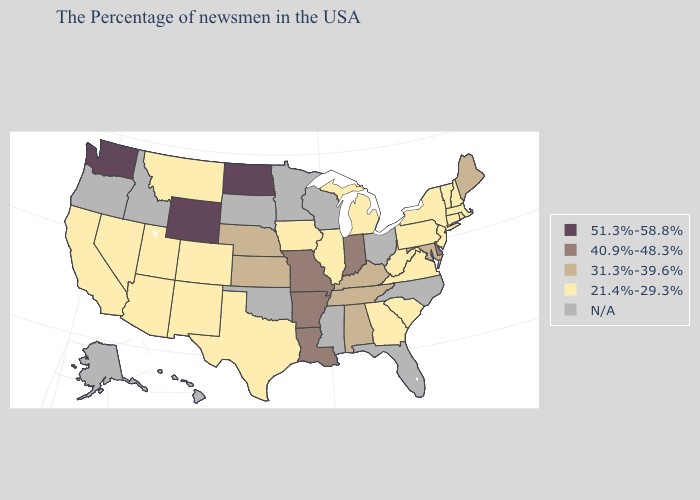What is the highest value in states that border Oregon?
Give a very brief answer. 51.3%-58.8%. What is the value of Indiana?
Answer briefly. 40.9%-48.3%. What is the value of Hawaii?
Write a very short answer. N/A. Among the states that border Ohio , does Kentucky have the highest value?
Keep it brief. No. What is the highest value in the USA?
Answer briefly. 51.3%-58.8%. Name the states that have a value in the range N/A?
Give a very brief answer. North Carolina, Ohio, Florida, Wisconsin, Mississippi, Minnesota, Oklahoma, South Dakota, Idaho, Oregon, Alaska, Hawaii. Which states have the lowest value in the Northeast?
Concise answer only. Massachusetts, Rhode Island, New Hampshire, Vermont, Connecticut, New York, New Jersey, Pennsylvania. What is the lowest value in the USA?
Be succinct. 21.4%-29.3%. What is the value of Illinois?
Quick response, please. 21.4%-29.3%. Does Washington have the highest value in the USA?
Quick response, please. Yes. What is the value of Maine?
Write a very short answer. 31.3%-39.6%. What is the value of Georgia?
Answer briefly. 21.4%-29.3%. 